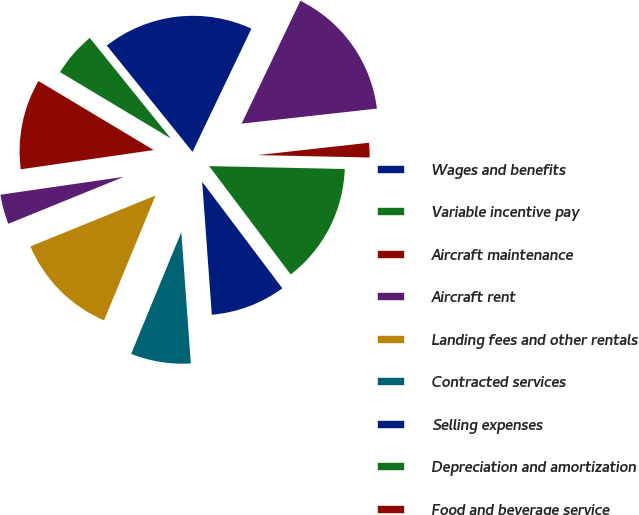<chart> <loc_0><loc_0><loc_500><loc_500><pie_chart><fcel>Wages and benefits<fcel>Variable incentive pay<fcel>Aircraft maintenance<fcel>Aircraft rent<fcel>Landing fees and other rentals<fcel>Contracted services<fcel>Selling expenses<fcel>Depreciation and amortization<fcel>Food and beverage service<fcel>Other<nl><fcel>17.9%<fcel>5.61%<fcel>10.88%<fcel>3.86%<fcel>12.63%<fcel>7.37%<fcel>9.12%<fcel>14.39%<fcel>2.1%<fcel>16.14%<nl></chart> 